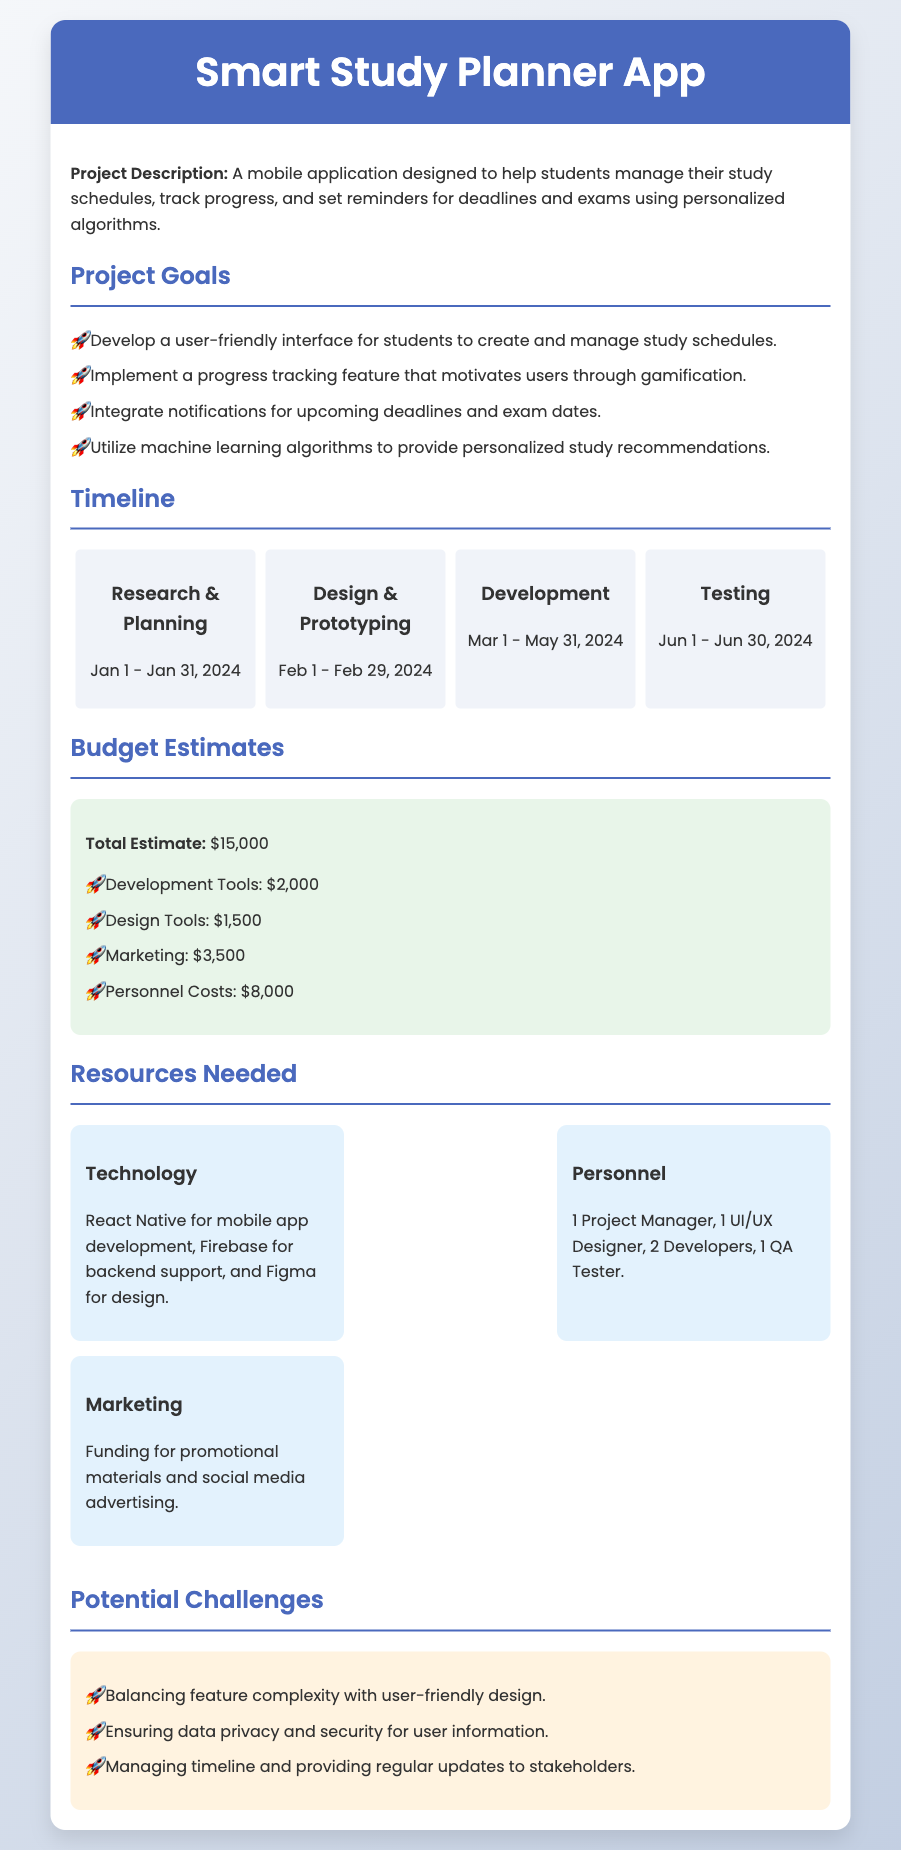What is the project name? The project name is mentioned in the title of the document as "Smart Study Planner App."
Answer: Smart Study Planner App What is the total budget estimate? The total budget estimate is specified in the budget section of the document as $15,000.
Answer: $15,000 Who is responsible for design? The personnel section specifies that there is one UI/UX Designer responsible for design.
Answer: UI/UX Designer What are the starting and ending dates for the Testing phase? The timeline shows that the Testing phase starts on June 1, 2024, and ends on June 30, 2024.
Answer: June 1 - June 30, 2024 What feature integrates notifications for deadlines? The document mentions a feature that integrates notifications as part of the project goals.
Answer: Notifications What is one potential challenge mentioned? The challenges section lists various challenges, one of which is balancing feature complexity with user-friendly design.
Answer: Balancing feature complexity with user-friendly design How many developers are needed? The resources needed outline that 2 Developers are required for the project.
Answer: 2 Developers What tool is suggested for mobile app development? The resources section states that React Native is the suggested tool for mobile app development.
Answer: React Native What is the duration of the Research & Planning phase? According to the timeline, the Research & Planning phase lasts from January 1, 2024, to January 31, 2024, a total of 31 days.
Answer: 31 days 